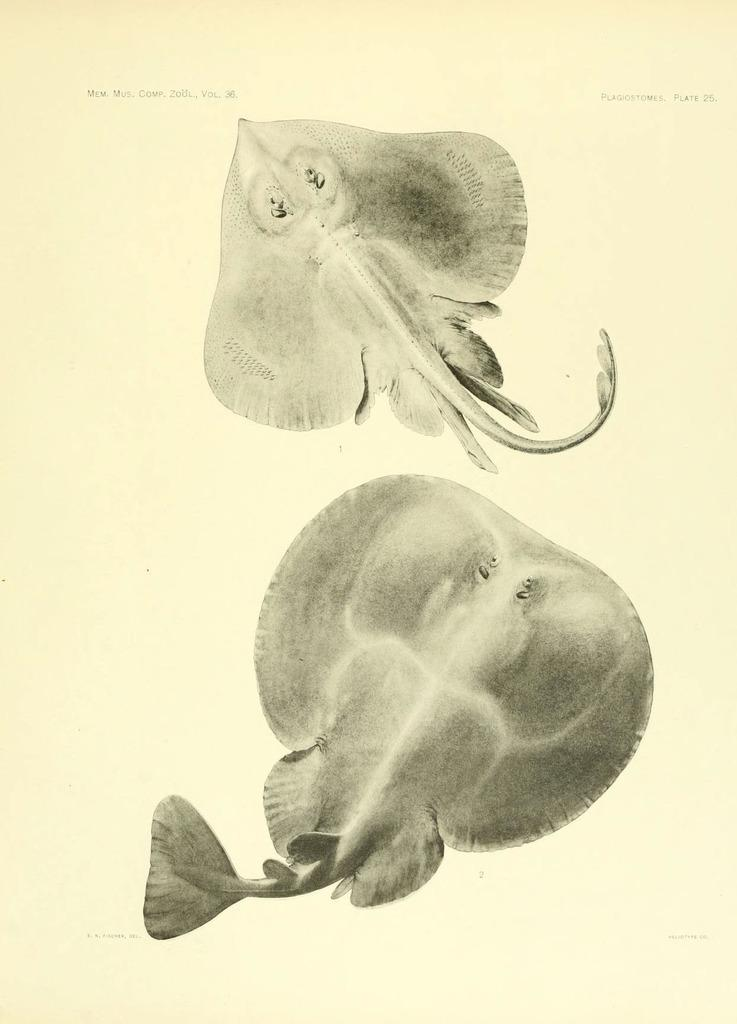What is depicted in the images in the picture? There are two fish images in the picture. What is the color of the surface where the images are placed? The images are on a white surface. Where can text be found in the image? There is text at the bottom and top of the image. What type of pet is shown in the image? There is no pet depicted in the image; it features two fish images. What kind of flag is visible in the image? There is no flag present in the image. 